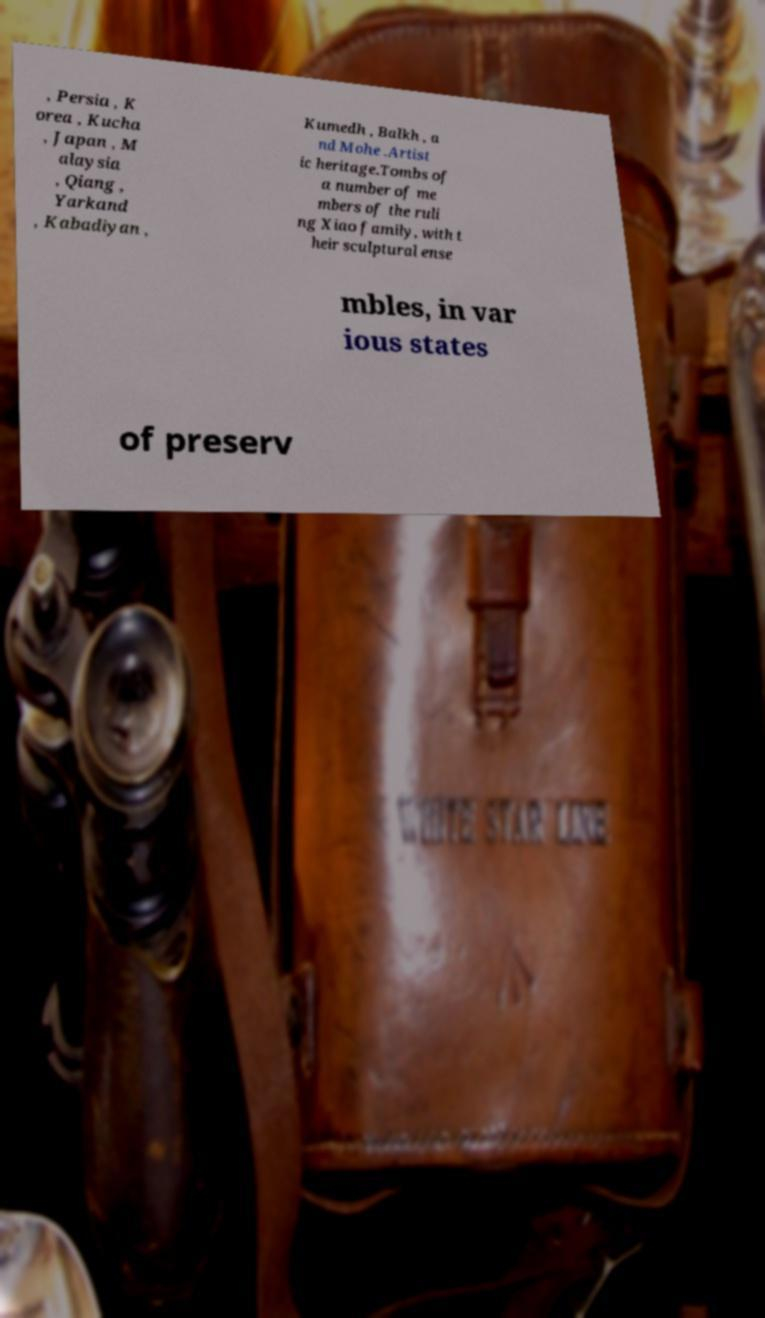For documentation purposes, I need the text within this image transcribed. Could you provide that? , Persia , K orea , Kucha , Japan , M alaysia , Qiang , Yarkand , Kabadiyan , Kumedh , Balkh , a nd Mohe .Artist ic heritage.Tombs of a number of me mbers of the ruli ng Xiao family, with t heir sculptural ense mbles, in var ious states of preserv 